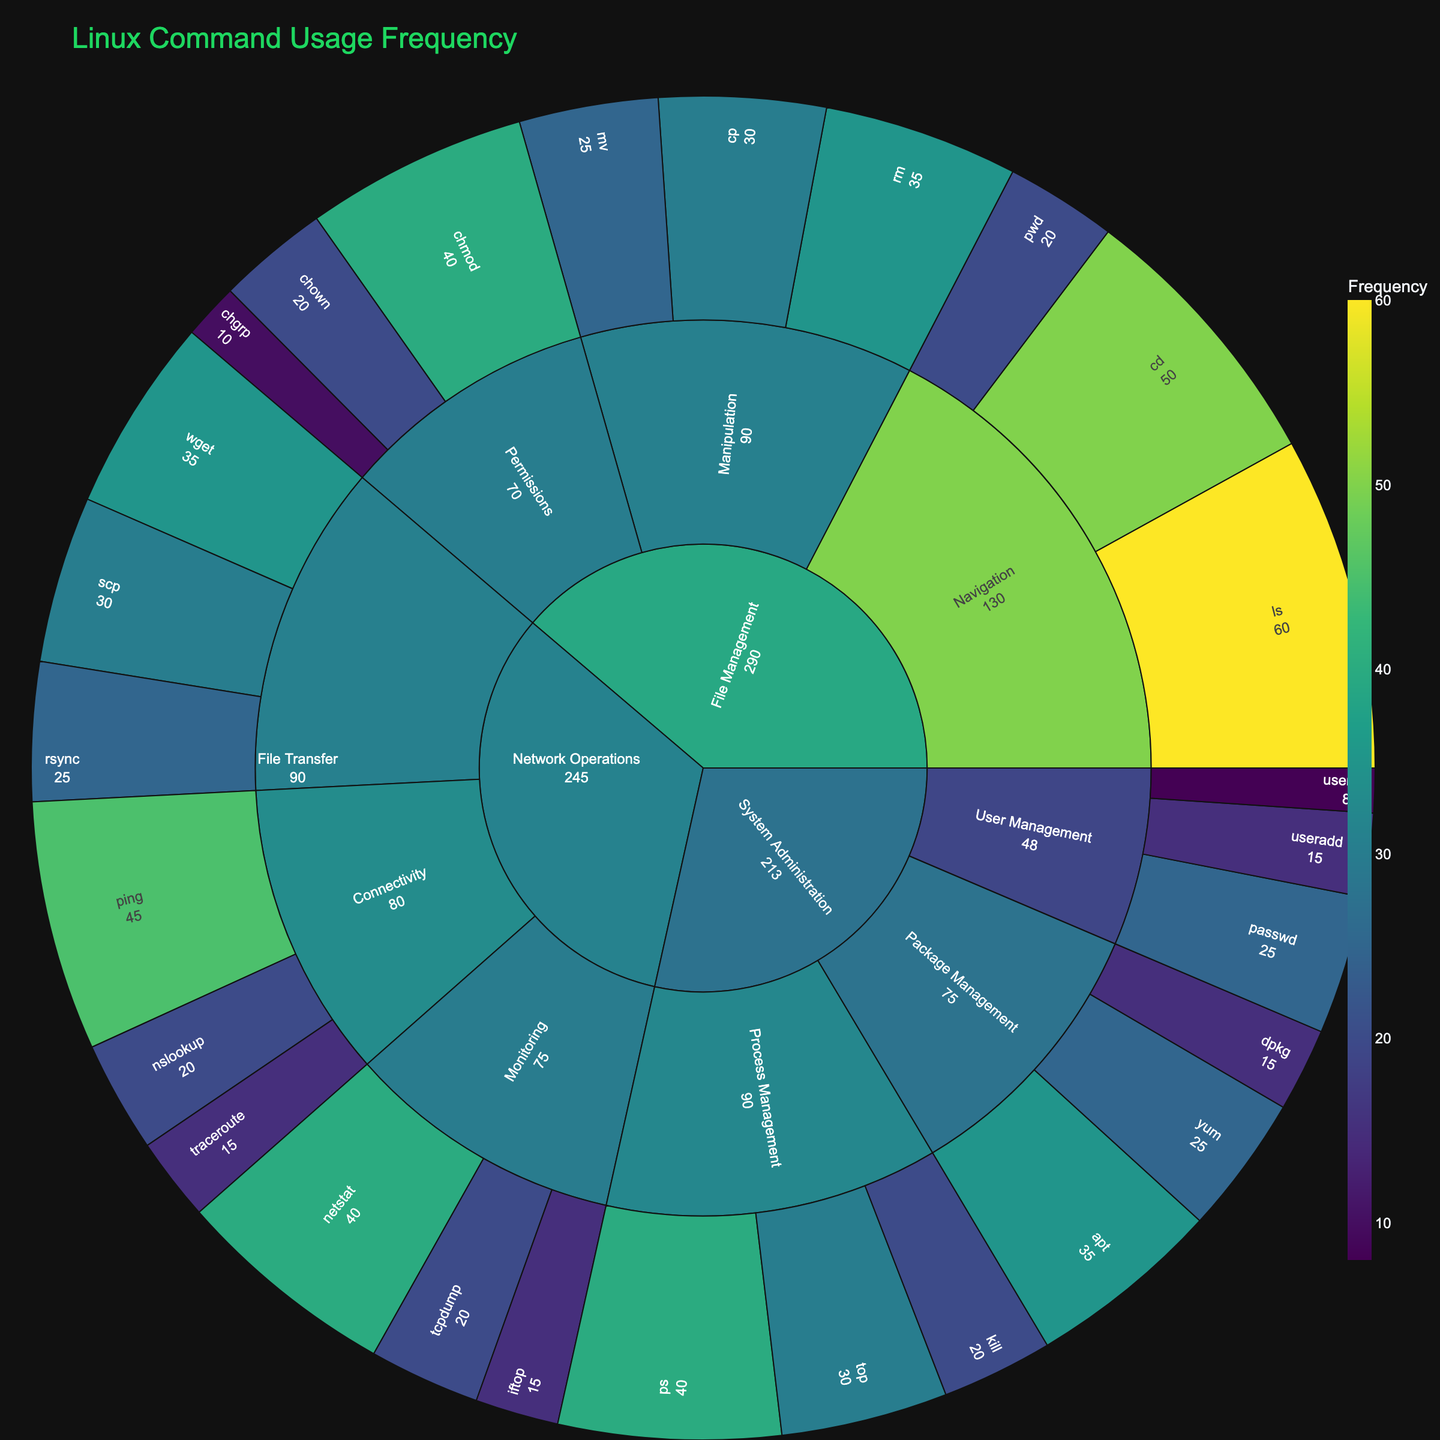what is the title of the plot? The title is displayed prominently at the top of the figure. It usually summarizes the main focus or subject of the plot.
Answer: Linux Command Usage Frequency What is the most frequently used command in the figure? The command with the highest numerical value in the 'frequency' field is the most frequently used.
Answer: ls Which category has the highest aggregate command usage? By summing the frequency values of all commands in each category, the category with the highest total is identified. Summing up the frequencies of each command in 'File Management' gives a total of 345, which is the highest.
Answer: File Management What's the difference in usage frequency between the most used 'Network Operations' command and the least used 'System Administration' command? The most used 'Network Operations' command is 'ping' with 45 occurrences, while the least used 'System Administration' command is 'userdel' with 8 occurrences. The difference is calculated as 45 - 8 = 37.
Answer: 37 How does the frequency of 'chmod' compare to 'chown' in 'File Management'? 'chmod' has a frequency of 40, and 'chown' has a frequency of 20. To compare, 40 is double 20, so 'chmod' is used twice as often as 'chown'.
Answer: chmod is used twice as often as chown What subcategory under 'System Administration' has the least total frequency? Summing frequencies within each subcategory of 'System Administration' reveals the subcategory with the smallest total. Adding up 'Process Management' yields 90, 'Package Management' yields 75, and 'User Management' yields 48. 'User Management' has the least total frequency.
Answer: User Management If the frequencies of 'scp', 'rsync', and 'wget' commands are combined, what would be the total frequency under 'File Transfer' in 'Network Operations'? Adding the frequencies of 'scp' (30), 'rsync' (25), and 'wget' (35) results in a total of 30 + 25 + 35 = 90 for 'File Transfer'.
Answer: 90 What color is likely used to denote high-frequency commands in the sunburst plot, given the color scale is 'Viridis'? The 'Viridis' color scale typically ranges from dark blues and purples to bright yellows and greens, with the high-frequency values usually represented by the brighter colors like yellow.
Answer: Yellow or bright colors Which command has the highest frequency within 'Process Management' in 'System Administration'? In 'Process Management', 'ps' has a frequency of 40, which is higher than 'top' (30) and 'kill' (20).
Answer: ps Under 'Network Operations', which subcategory has the highest total command usage frequency? Summing the frequencies within each subcategory of 'Network Operations' identifies the one with the highest total. 'Connectivity' sums to 80, 'File Transfer' sums to 90, and 'Monitoring' sums to 75. 'File Transfer' has the highest total command usage frequency.
Answer: File Transfer 